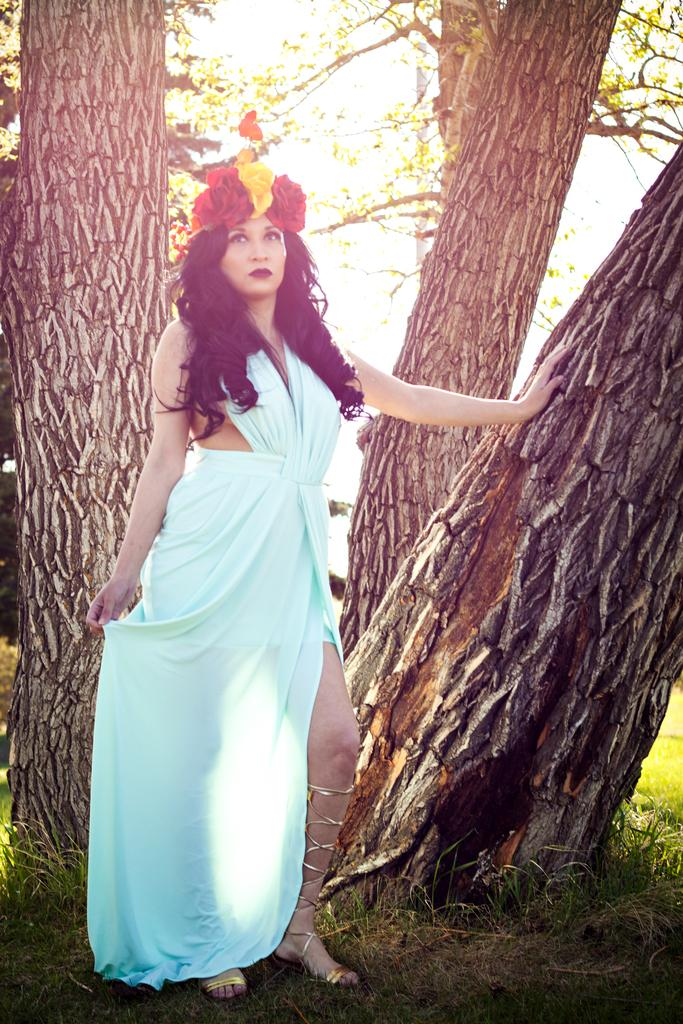Who is the main subject in the image? There is a woman in the image. What is the woman's position in the image? The woman is standing on the ground. What can be seen in the background of the image? There are trees in the background of the image. What type of zephyr can be seen blowing through the woman's hair in the image? There is no zephyr present in the image, and the woman's hair is not being blown by any wind. 